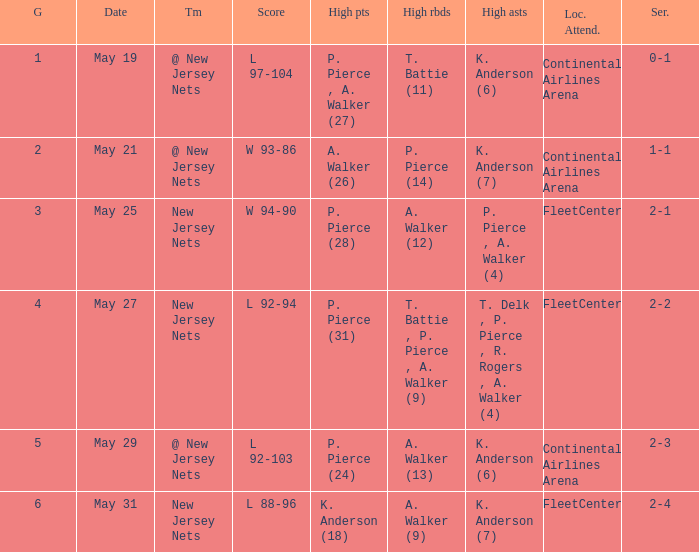What was the highest assists for game 3? P. Pierce , A. Walker (4). 